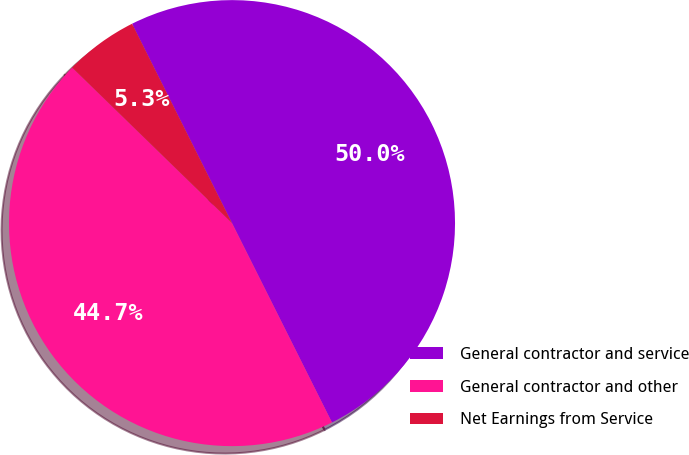<chart> <loc_0><loc_0><loc_500><loc_500><pie_chart><fcel>General contractor and service<fcel>General contractor and other<fcel>Net Earnings from Service<nl><fcel>50.0%<fcel>44.68%<fcel>5.32%<nl></chart> 